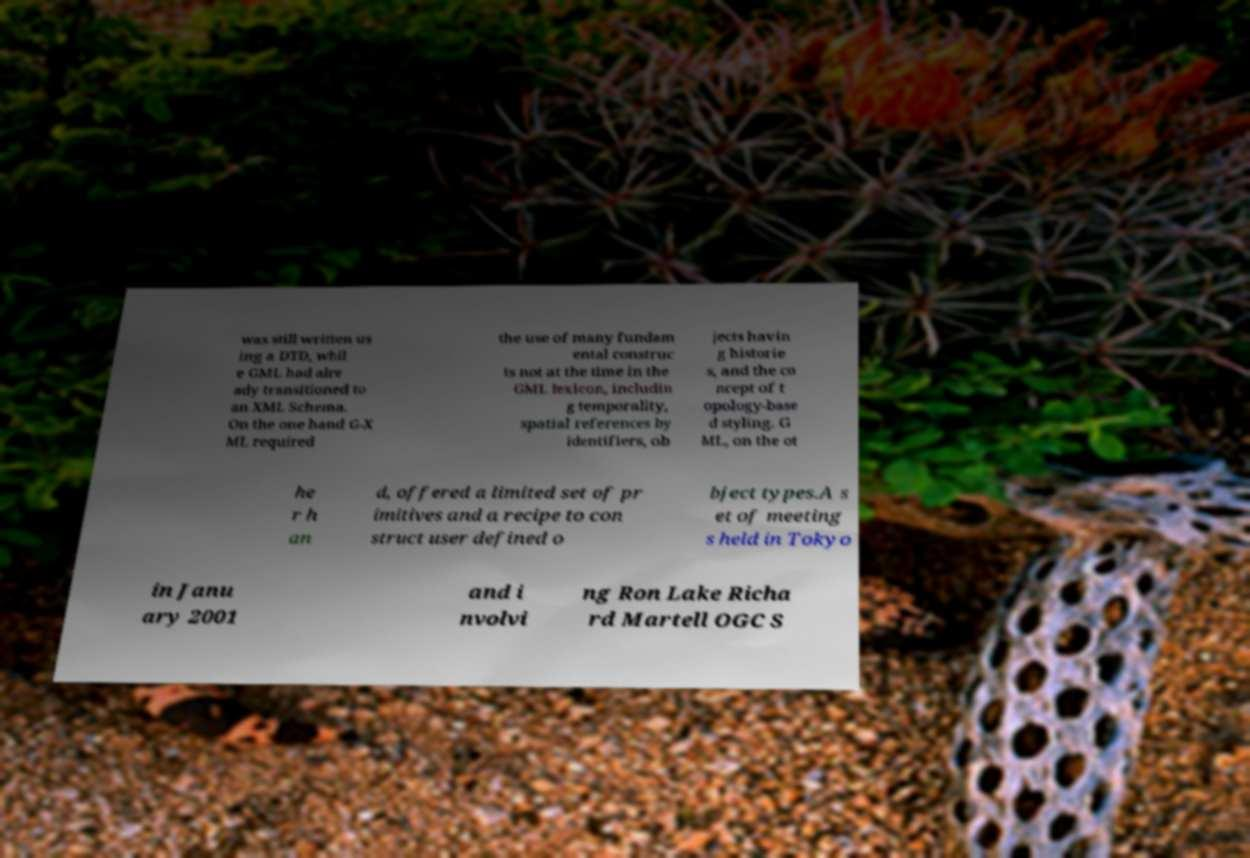Please identify and transcribe the text found in this image. was still written us ing a DTD, whil e GML had alre ady transitioned to an XML Schema. On the one hand G-X ML required the use of many fundam ental construc ts not at the time in the GML lexicon, includin g temporality, spatial references by identifiers, ob jects havin g historie s, and the co ncept of t opology-base d styling. G ML, on the ot he r h an d, offered a limited set of pr imitives and a recipe to con struct user defined o bject types.A s et of meeting s held in Tokyo in Janu ary 2001 and i nvolvi ng Ron Lake Richa rd Martell OGC S 